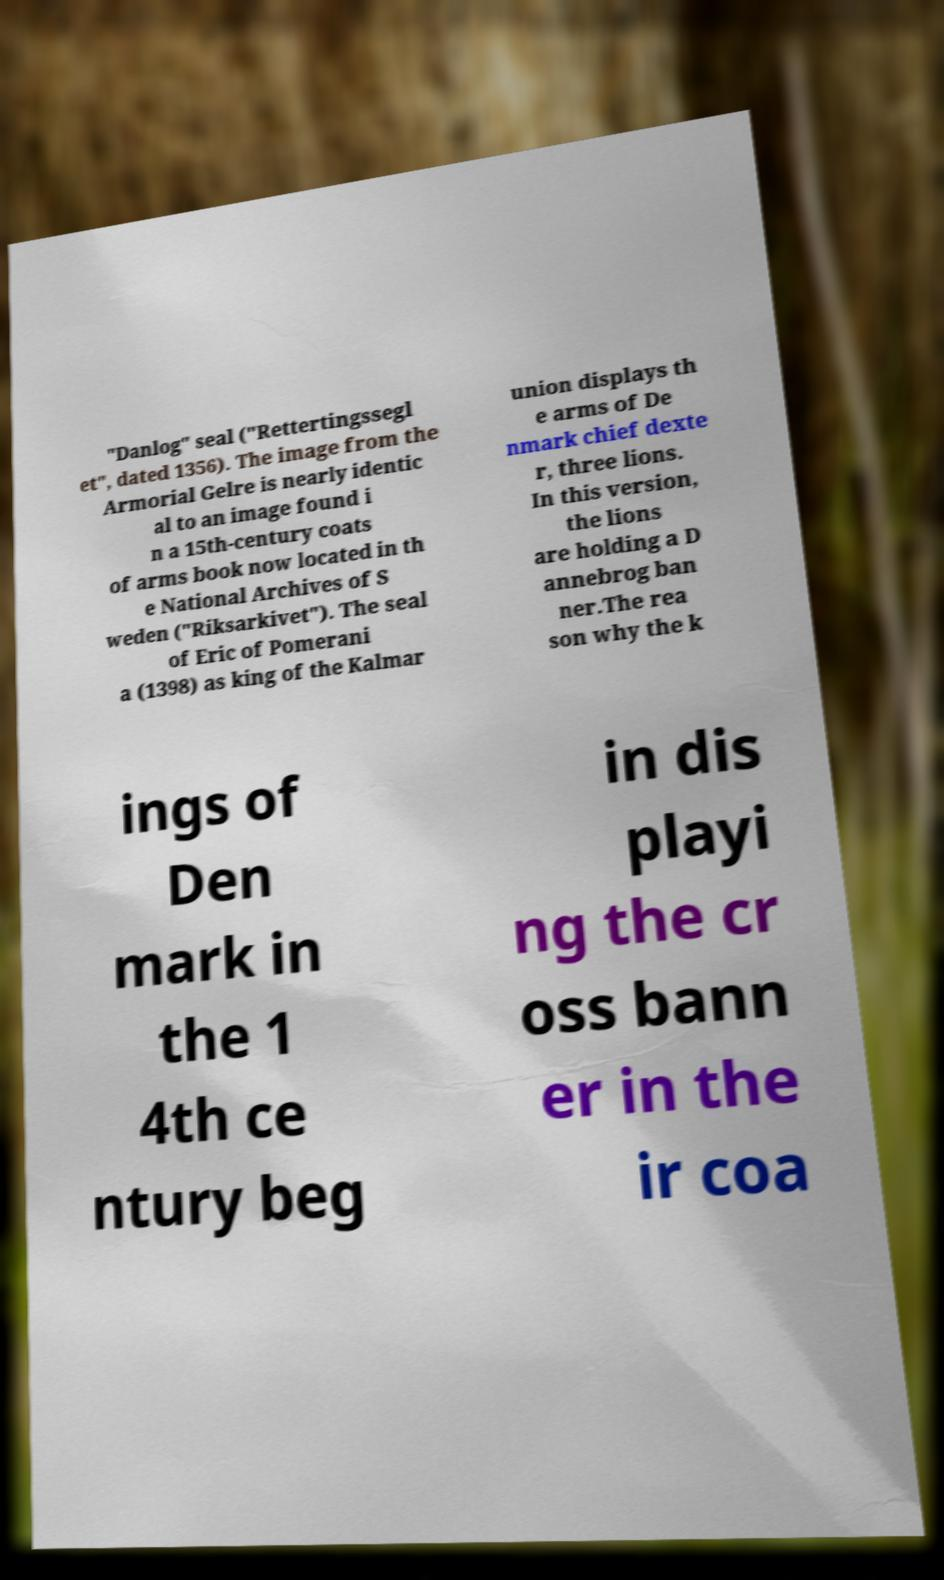Please identify and transcribe the text found in this image. "Danlog" seal ("Rettertingssegl et", dated 1356). The image from the Armorial Gelre is nearly identic al to an image found i n a 15th-century coats of arms book now located in th e National Archives of S weden ("Riksarkivet"). The seal of Eric of Pomerani a (1398) as king of the Kalmar union displays th e arms of De nmark chief dexte r, three lions. In this version, the lions are holding a D annebrog ban ner.The rea son why the k ings of Den mark in the 1 4th ce ntury beg in dis playi ng the cr oss bann er in the ir coa 